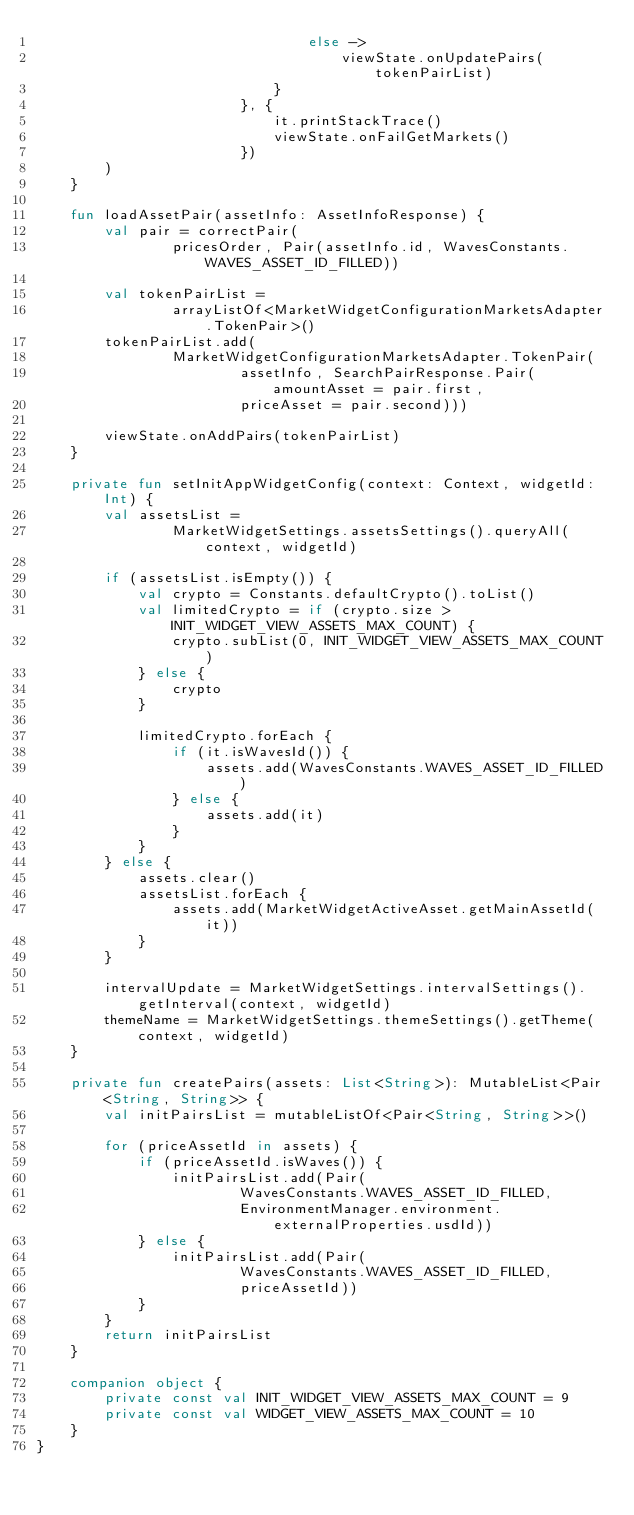<code> <loc_0><loc_0><loc_500><loc_500><_Kotlin_>                                else ->
                                    viewState.onUpdatePairs(tokenPairList)
                            }
                        }, {
                            it.printStackTrace()
                            viewState.onFailGetMarkets()
                        })
        )
    }

    fun loadAssetPair(assetInfo: AssetInfoResponse) {
        val pair = correctPair(
                pricesOrder, Pair(assetInfo.id, WavesConstants.WAVES_ASSET_ID_FILLED))

        val tokenPairList =
                arrayListOf<MarketWidgetConfigurationMarketsAdapter.TokenPair>()
        tokenPairList.add(
                MarketWidgetConfigurationMarketsAdapter.TokenPair(
                        assetInfo, SearchPairResponse.Pair(amountAsset = pair.first,
                        priceAsset = pair.second)))

        viewState.onAddPairs(tokenPairList)
    }

    private fun setInitAppWidgetConfig(context: Context, widgetId: Int) {
        val assetsList =
                MarketWidgetSettings.assetsSettings().queryAll(context, widgetId)

        if (assetsList.isEmpty()) {
            val crypto = Constants.defaultCrypto().toList()
            val limitedCrypto = if (crypto.size > INIT_WIDGET_VIEW_ASSETS_MAX_COUNT) {
                crypto.subList(0, INIT_WIDGET_VIEW_ASSETS_MAX_COUNT)
            } else {
                crypto
            }

            limitedCrypto.forEach {
                if (it.isWavesId()) {
                    assets.add(WavesConstants.WAVES_ASSET_ID_FILLED)
                } else {
                    assets.add(it)
                }
            }
        } else {
            assets.clear()
            assetsList.forEach {
                assets.add(MarketWidgetActiveAsset.getMainAssetId(it))
            }
        }

        intervalUpdate = MarketWidgetSettings.intervalSettings().getInterval(context, widgetId)
        themeName = MarketWidgetSettings.themeSettings().getTheme(context, widgetId)
    }

    private fun createPairs(assets: List<String>): MutableList<Pair<String, String>> {
        val initPairsList = mutableListOf<Pair<String, String>>()

        for (priceAssetId in assets) {
            if (priceAssetId.isWaves()) {
                initPairsList.add(Pair(
                        WavesConstants.WAVES_ASSET_ID_FILLED,
                        EnvironmentManager.environment.externalProperties.usdId))
            } else {
                initPairsList.add(Pair(
                        WavesConstants.WAVES_ASSET_ID_FILLED,
                        priceAssetId))
            }
        }
        return initPairsList
    }

    companion object {
        private const val INIT_WIDGET_VIEW_ASSETS_MAX_COUNT = 9
        private const val WIDGET_VIEW_ASSETS_MAX_COUNT = 10
    }
}</code> 